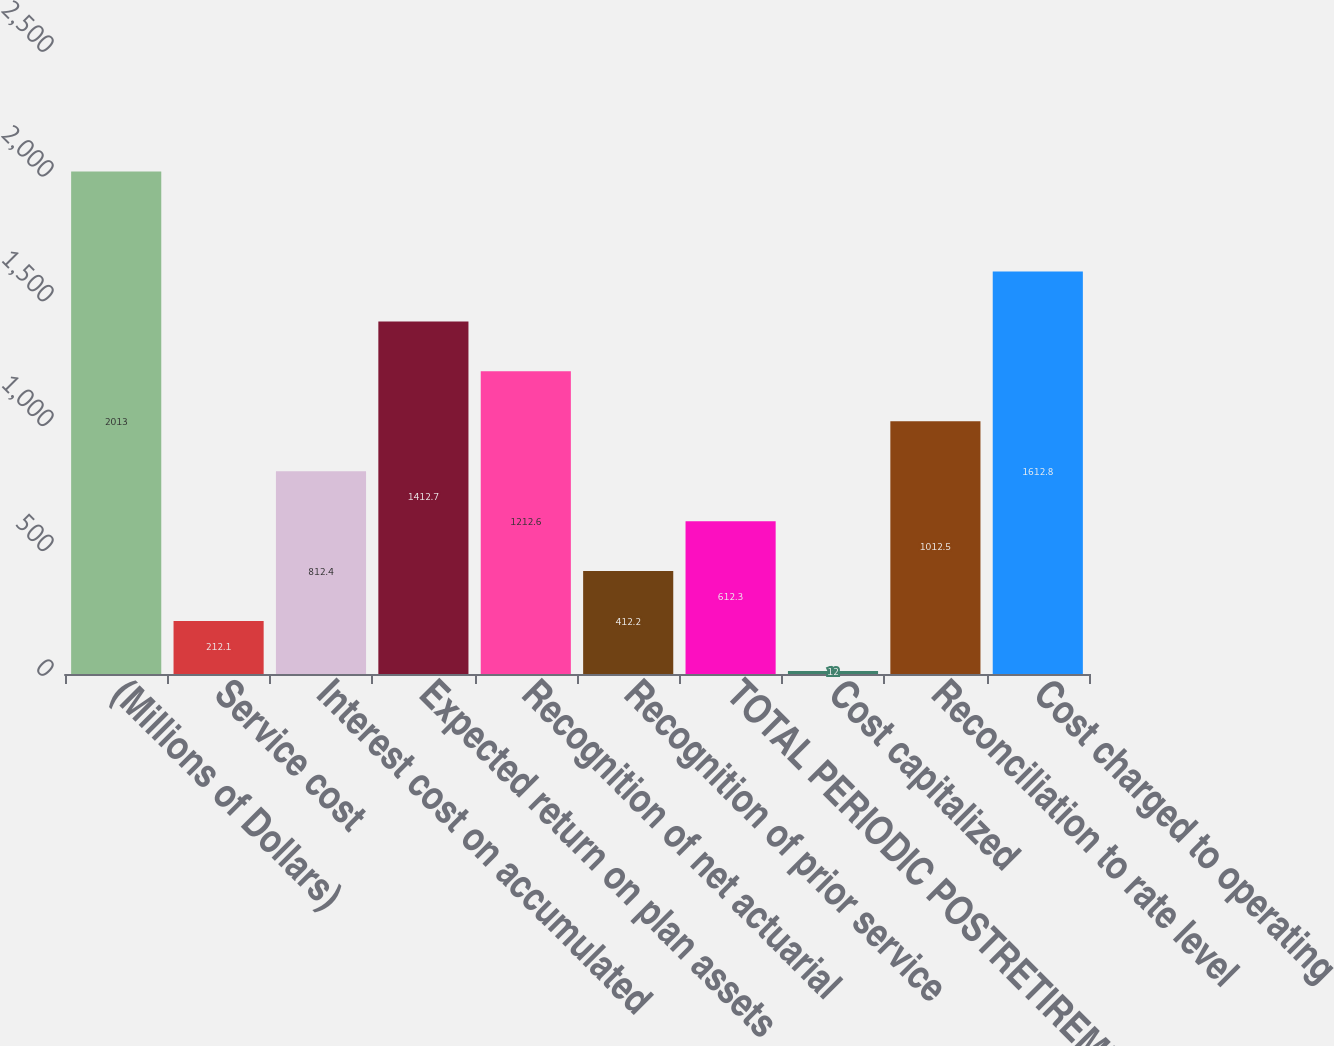<chart> <loc_0><loc_0><loc_500><loc_500><bar_chart><fcel>(Millions of Dollars)<fcel>Service cost<fcel>Interest cost on accumulated<fcel>Expected return on plan assets<fcel>Recognition of net actuarial<fcel>Recognition of prior service<fcel>TOTAL PERIODIC POSTRETIREMENT<fcel>Cost capitalized<fcel>Reconciliation to rate level<fcel>Cost charged to operating<nl><fcel>2013<fcel>212.1<fcel>812.4<fcel>1412.7<fcel>1212.6<fcel>412.2<fcel>612.3<fcel>12<fcel>1012.5<fcel>1612.8<nl></chart> 